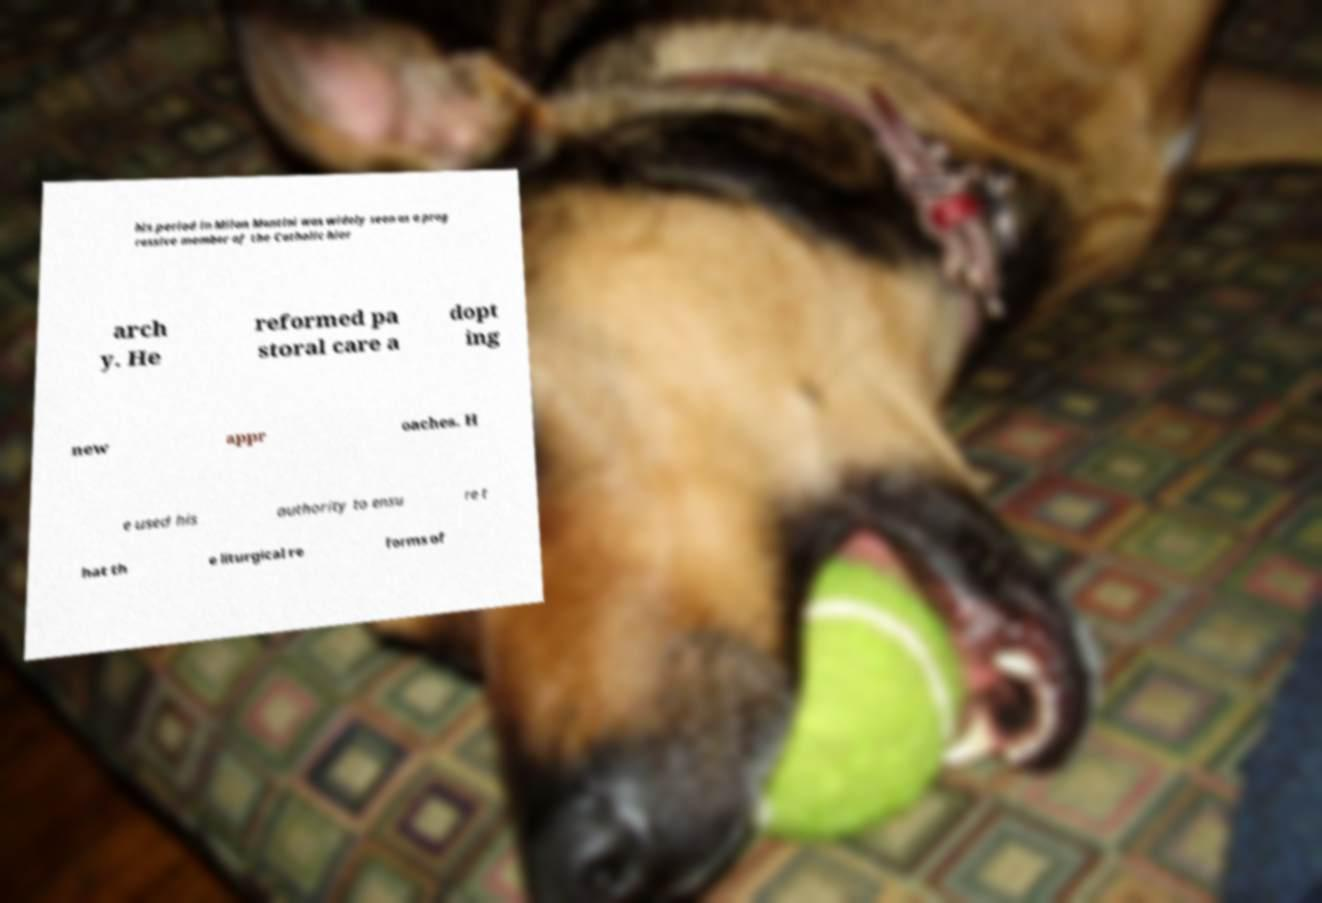Can you accurately transcribe the text from the provided image for me? his period in Milan Montini was widely seen as a prog ressive member of the Catholic hier arch y. He reformed pa storal care a dopt ing new appr oaches. H e used his authority to ensu re t hat th e liturgical re forms of 